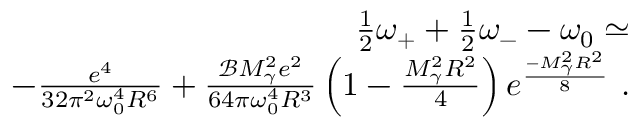Convert formula to latex. <formula><loc_0><loc_0><loc_500><loc_500>\begin{array} { r l r } & { \frac { 1 } { 2 } \omega _ { + } + \frac { 1 } { 2 } \omega _ { - } - \omega _ { 0 } \simeq } \\ & { - \frac { e ^ { 4 } } { 3 2 \pi ^ { 2 } \omega _ { 0 } ^ { 4 } R ^ { 6 } } + \frac { \mathcal { B } M _ { \gamma } ^ { 2 } e ^ { 2 } } { 6 4 \pi \omega _ { 0 } ^ { 4 } R ^ { 3 } } \left ( 1 - \frac { M _ { \gamma } ^ { 2 } R ^ { 2 } } { 4 } \right ) e ^ { \frac { - M _ { \gamma } ^ { 2 } R ^ { 2 } } { 8 } } \ . } \end{array}</formula> 